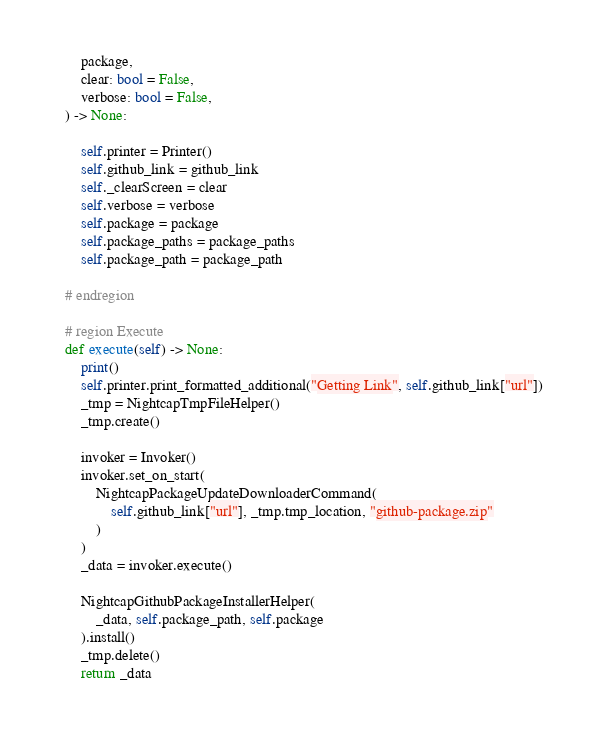Convert code to text. <code><loc_0><loc_0><loc_500><loc_500><_Python_>        package,
        clear: bool = False,
        verbose: bool = False,
    ) -> None:

        self.printer = Printer()
        self.github_link = github_link
        self._clearScreen = clear
        self.verbose = verbose
        self.package = package
        self.package_paths = package_paths
        self.package_path = package_path

    # endregion

    # region Execute
    def execute(self) -> None:
        print()
        self.printer.print_formatted_additional("Getting Link", self.github_link["url"])
        _tmp = NightcapTmpFileHelper()
        _tmp.create()

        invoker = Invoker()
        invoker.set_on_start(
            NightcapPackageUpdateDownloaderCommand(
                self.github_link["url"], _tmp.tmp_location, "github-package.zip"
            )
        )
        _data = invoker.execute()

        NightcapGithubPackageInstallerHelper(
            _data, self.package_path, self.package
        ).install()
        _tmp.delete()
        return _data
</code> 